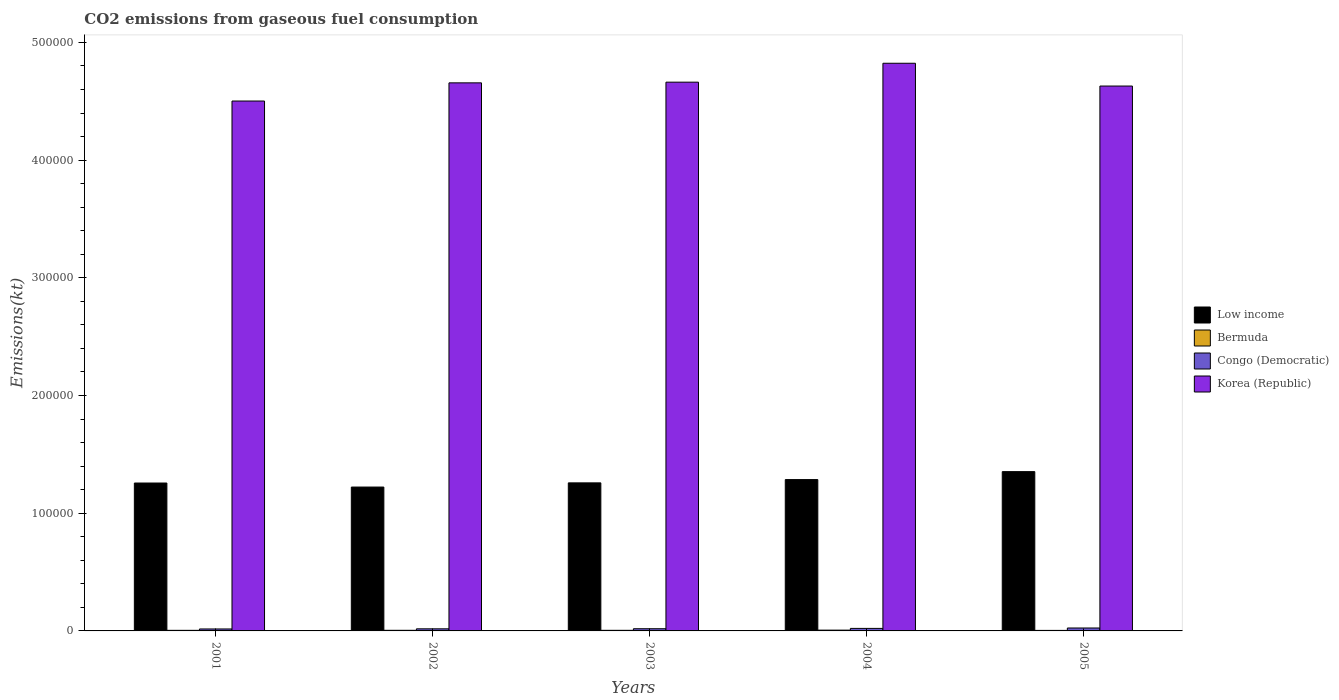How many different coloured bars are there?
Provide a succinct answer. 4. How many groups of bars are there?
Offer a very short reply. 5. Are the number of bars on each tick of the X-axis equal?
Provide a succinct answer. Yes. How many bars are there on the 2nd tick from the left?
Offer a terse response. 4. What is the label of the 1st group of bars from the left?
Ensure brevity in your answer.  2001. What is the amount of CO2 emitted in Korea (Republic) in 2002?
Keep it short and to the point. 4.66e+05. Across all years, what is the maximum amount of CO2 emitted in Congo (Democratic)?
Your answer should be compact. 2486.23. Across all years, what is the minimum amount of CO2 emitted in Congo (Democratic)?
Ensure brevity in your answer.  1664.82. In which year was the amount of CO2 emitted in Bermuda minimum?
Make the answer very short. 2005. What is the total amount of CO2 emitted in Bermuda in the graph?
Ensure brevity in your answer.  2643.91. What is the difference between the amount of CO2 emitted in Bermuda in 2003 and that in 2005?
Offer a very short reply. 66.01. What is the difference between the amount of CO2 emitted in Bermuda in 2003 and the amount of CO2 emitted in Korea (Republic) in 2004?
Give a very brief answer. -4.82e+05. What is the average amount of CO2 emitted in Congo (Democratic) per year?
Offer a terse response. 1986.78. In the year 2001, what is the difference between the amount of CO2 emitted in Congo (Democratic) and amount of CO2 emitted in Low income?
Give a very brief answer. -1.24e+05. What is the ratio of the amount of CO2 emitted in Korea (Republic) in 2001 to that in 2003?
Offer a very short reply. 0.97. Is the amount of CO2 emitted in Bermuda in 2002 less than that in 2005?
Give a very brief answer. No. Is the difference between the amount of CO2 emitted in Congo (Democratic) in 2003 and 2004 greater than the difference between the amount of CO2 emitted in Low income in 2003 and 2004?
Your response must be concise. Yes. What is the difference between the highest and the second highest amount of CO2 emitted in Bermuda?
Give a very brief answer. 146.68. What is the difference between the highest and the lowest amount of CO2 emitted in Bermuda?
Give a very brief answer. 227.35. In how many years, is the amount of CO2 emitted in Low income greater than the average amount of CO2 emitted in Low income taken over all years?
Ensure brevity in your answer.  2. Is the sum of the amount of CO2 emitted in Low income in 2002 and 2004 greater than the maximum amount of CO2 emitted in Congo (Democratic) across all years?
Provide a short and direct response. Yes. Is it the case that in every year, the sum of the amount of CO2 emitted in Bermuda and amount of CO2 emitted in Congo (Democratic) is greater than the sum of amount of CO2 emitted in Low income and amount of CO2 emitted in Korea (Republic)?
Offer a terse response. No. How many bars are there?
Keep it short and to the point. 20. How many years are there in the graph?
Give a very brief answer. 5. Are the values on the major ticks of Y-axis written in scientific E-notation?
Your response must be concise. No. Does the graph contain grids?
Provide a succinct answer. No. How are the legend labels stacked?
Your answer should be compact. Vertical. What is the title of the graph?
Give a very brief answer. CO2 emissions from gaseous fuel consumption. What is the label or title of the Y-axis?
Give a very brief answer. Emissions(kt). What is the Emissions(kt) in Low income in 2001?
Your answer should be compact. 1.26e+05. What is the Emissions(kt) of Bermuda in 2001?
Your answer should be compact. 495.05. What is the Emissions(kt) of Congo (Democratic) in 2001?
Offer a very short reply. 1664.82. What is the Emissions(kt) of Korea (Republic) in 2001?
Offer a terse response. 4.50e+05. What is the Emissions(kt) in Low income in 2002?
Make the answer very short. 1.22e+05. What is the Emissions(kt) of Bermuda in 2002?
Make the answer very short. 524.38. What is the Emissions(kt) of Congo (Democratic) in 2002?
Ensure brevity in your answer.  1782.16. What is the Emissions(kt) in Korea (Republic) in 2002?
Ensure brevity in your answer.  4.66e+05. What is the Emissions(kt) in Low income in 2003?
Make the answer very short. 1.26e+05. What is the Emissions(kt) of Bermuda in 2003?
Provide a succinct answer. 509.71. What is the Emissions(kt) of Congo (Democratic) in 2003?
Provide a succinct answer. 1862.84. What is the Emissions(kt) of Korea (Republic) in 2003?
Keep it short and to the point. 4.66e+05. What is the Emissions(kt) in Low income in 2004?
Offer a very short reply. 1.29e+05. What is the Emissions(kt) in Bermuda in 2004?
Ensure brevity in your answer.  671.06. What is the Emissions(kt) of Congo (Democratic) in 2004?
Ensure brevity in your answer.  2137.86. What is the Emissions(kt) in Korea (Republic) in 2004?
Provide a short and direct response. 4.82e+05. What is the Emissions(kt) of Low income in 2005?
Keep it short and to the point. 1.35e+05. What is the Emissions(kt) in Bermuda in 2005?
Ensure brevity in your answer.  443.71. What is the Emissions(kt) in Congo (Democratic) in 2005?
Keep it short and to the point. 2486.23. What is the Emissions(kt) in Korea (Republic) in 2005?
Your answer should be very brief. 4.63e+05. Across all years, what is the maximum Emissions(kt) of Low income?
Offer a terse response. 1.35e+05. Across all years, what is the maximum Emissions(kt) in Bermuda?
Make the answer very short. 671.06. Across all years, what is the maximum Emissions(kt) in Congo (Democratic)?
Provide a short and direct response. 2486.23. Across all years, what is the maximum Emissions(kt) in Korea (Republic)?
Keep it short and to the point. 4.82e+05. Across all years, what is the minimum Emissions(kt) of Low income?
Keep it short and to the point. 1.22e+05. Across all years, what is the minimum Emissions(kt) of Bermuda?
Your answer should be very brief. 443.71. Across all years, what is the minimum Emissions(kt) in Congo (Democratic)?
Provide a succinct answer. 1664.82. Across all years, what is the minimum Emissions(kt) of Korea (Republic)?
Give a very brief answer. 4.50e+05. What is the total Emissions(kt) in Low income in the graph?
Your response must be concise. 6.38e+05. What is the total Emissions(kt) of Bermuda in the graph?
Give a very brief answer. 2643.91. What is the total Emissions(kt) of Congo (Democratic) in the graph?
Provide a succinct answer. 9933.9. What is the total Emissions(kt) in Korea (Republic) in the graph?
Provide a short and direct response. 2.33e+06. What is the difference between the Emissions(kt) in Low income in 2001 and that in 2002?
Keep it short and to the point. 3417.64. What is the difference between the Emissions(kt) in Bermuda in 2001 and that in 2002?
Ensure brevity in your answer.  -29.34. What is the difference between the Emissions(kt) in Congo (Democratic) in 2001 and that in 2002?
Provide a succinct answer. -117.34. What is the difference between the Emissions(kt) in Korea (Republic) in 2001 and that in 2002?
Offer a terse response. -1.54e+04. What is the difference between the Emissions(kt) of Low income in 2001 and that in 2003?
Provide a short and direct response. -132.01. What is the difference between the Emissions(kt) of Bermuda in 2001 and that in 2003?
Make the answer very short. -14.67. What is the difference between the Emissions(kt) in Congo (Democratic) in 2001 and that in 2003?
Your answer should be compact. -198.02. What is the difference between the Emissions(kt) of Korea (Republic) in 2001 and that in 2003?
Give a very brief answer. -1.60e+04. What is the difference between the Emissions(kt) in Low income in 2001 and that in 2004?
Provide a succinct answer. -2926.27. What is the difference between the Emissions(kt) of Bermuda in 2001 and that in 2004?
Offer a very short reply. -176.02. What is the difference between the Emissions(kt) of Congo (Democratic) in 2001 and that in 2004?
Keep it short and to the point. -473.04. What is the difference between the Emissions(kt) of Korea (Republic) in 2001 and that in 2004?
Offer a very short reply. -3.21e+04. What is the difference between the Emissions(kt) of Low income in 2001 and that in 2005?
Ensure brevity in your answer.  -9673.55. What is the difference between the Emissions(kt) in Bermuda in 2001 and that in 2005?
Make the answer very short. 51.34. What is the difference between the Emissions(kt) of Congo (Democratic) in 2001 and that in 2005?
Keep it short and to the point. -821.41. What is the difference between the Emissions(kt) of Korea (Republic) in 2001 and that in 2005?
Offer a very short reply. -1.27e+04. What is the difference between the Emissions(kt) of Low income in 2002 and that in 2003?
Your answer should be compact. -3549.66. What is the difference between the Emissions(kt) of Bermuda in 2002 and that in 2003?
Offer a terse response. 14.67. What is the difference between the Emissions(kt) of Congo (Democratic) in 2002 and that in 2003?
Your response must be concise. -80.67. What is the difference between the Emissions(kt) in Korea (Republic) in 2002 and that in 2003?
Offer a terse response. -583.05. What is the difference between the Emissions(kt) in Low income in 2002 and that in 2004?
Ensure brevity in your answer.  -6343.91. What is the difference between the Emissions(kt) of Bermuda in 2002 and that in 2004?
Provide a short and direct response. -146.68. What is the difference between the Emissions(kt) of Congo (Democratic) in 2002 and that in 2004?
Provide a succinct answer. -355.7. What is the difference between the Emissions(kt) in Korea (Republic) in 2002 and that in 2004?
Give a very brief answer. -1.66e+04. What is the difference between the Emissions(kt) in Low income in 2002 and that in 2005?
Keep it short and to the point. -1.31e+04. What is the difference between the Emissions(kt) of Bermuda in 2002 and that in 2005?
Provide a succinct answer. 80.67. What is the difference between the Emissions(kt) in Congo (Democratic) in 2002 and that in 2005?
Give a very brief answer. -704.06. What is the difference between the Emissions(kt) of Korea (Republic) in 2002 and that in 2005?
Your response must be concise. 2709.91. What is the difference between the Emissions(kt) in Low income in 2003 and that in 2004?
Ensure brevity in your answer.  -2794.25. What is the difference between the Emissions(kt) in Bermuda in 2003 and that in 2004?
Your answer should be very brief. -161.35. What is the difference between the Emissions(kt) in Congo (Democratic) in 2003 and that in 2004?
Offer a very short reply. -275.02. What is the difference between the Emissions(kt) in Korea (Republic) in 2003 and that in 2004?
Offer a terse response. -1.61e+04. What is the difference between the Emissions(kt) in Low income in 2003 and that in 2005?
Make the answer very short. -9541.53. What is the difference between the Emissions(kt) of Bermuda in 2003 and that in 2005?
Your answer should be compact. 66.01. What is the difference between the Emissions(kt) of Congo (Democratic) in 2003 and that in 2005?
Give a very brief answer. -623.39. What is the difference between the Emissions(kt) of Korea (Republic) in 2003 and that in 2005?
Provide a short and direct response. 3292.97. What is the difference between the Emissions(kt) in Low income in 2004 and that in 2005?
Ensure brevity in your answer.  -6747.28. What is the difference between the Emissions(kt) of Bermuda in 2004 and that in 2005?
Offer a terse response. 227.35. What is the difference between the Emissions(kt) of Congo (Democratic) in 2004 and that in 2005?
Your response must be concise. -348.37. What is the difference between the Emissions(kt) in Korea (Republic) in 2004 and that in 2005?
Your answer should be compact. 1.94e+04. What is the difference between the Emissions(kt) of Low income in 2001 and the Emissions(kt) of Bermuda in 2002?
Provide a short and direct response. 1.25e+05. What is the difference between the Emissions(kt) in Low income in 2001 and the Emissions(kt) in Congo (Democratic) in 2002?
Keep it short and to the point. 1.24e+05. What is the difference between the Emissions(kt) in Low income in 2001 and the Emissions(kt) in Korea (Republic) in 2002?
Keep it short and to the point. -3.40e+05. What is the difference between the Emissions(kt) of Bermuda in 2001 and the Emissions(kt) of Congo (Democratic) in 2002?
Ensure brevity in your answer.  -1287.12. What is the difference between the Emissions(kt) of Bermuda in 2001 and the Emissions(kt) of Korea (Republic) in 2002?
Your response must be concise. -4.65e+05. What is the difference between the Emissions(kt) of Congo (Democratic) in 2001 and the Emissions(kt) of Korea (Republic) in 2002?
Provide a short and direct response. -4.64e+05. What is the difference between the Emissions(kt) in Low income in 2001 and the Emissions(kt) in Bermuda in 2003?
Provide a short and direct response. 1.25e+05. What is the difference between the Emissions(kt) in Low income in 2001 and the Emissions(kt) in Congo (Democratic) in 2003?
Offer a very short reply. 1.24e+05. What is the difference between the Emissions(kt) in Low income in 2001 and the Emissions(kt) in Korea (Republic) in 2003?
Your answer should be very brief. -3.41e+05. What is the difference between the Emissions(kt) of Bermuda in 2001 and the Emissions(kt) of Congo (Democratic) in 2003?
Ensure brevity in your answer.  -1367.79. What is the difference between the Emissions(kt) in Bermuda in 2001 and the Emissions(kt) in Korea (Republic) in 2003?
Offer a very short reply. -4.66e+05. What is the difference between the Emissions(kt) of Congo (Democratic) in 2001 and the Emissions(kt) of Korea (Republic) in 2003?
Offer a terse response. -4.65e+05. What is the difference between the Emissions(kt) of Low income in 2001 and the Emissions(kt) of Bermuda in 2004?
Provide a succinct answer. 1.25e+05. What is the difference between the Emissions(kt) in Low income in 2001 and the Emissions(kt) in Congo (Democratic) in 2004?
Your answer should be compact. 1.24e+05. What is the difference between the Emissions(kt) of Low income in 2001 and the Emissions(kt) of Korea (Republic) in 2004?
Provide a succinct answer. -3.57e+05. What is the difference between the Emissions(kt) in Bermuda in 2001 and the Emissions(kt) in Congo (Democratic) in 2004?
Keep it short and to the point. -1642.82. What is the difference between the Emissions(kt) in Bermuda in 2001 and the Emissions(kt) in Korea (Republic) in 2004?
Your answer should be very brief. -4.82e+05. What is the difference between the Emissions(kt) in Congo (Democratic) in 2001 and the Emissions(kt) in Korea (Republic) in 2004?
Keep it short and to the point. -4.81e+05. What is the difference between the Emissions(kt) of Low income in 2001 and the Emissions(kt) of Bermuda in 2005?
Offer a terse response. 1.25e+05. What is the difference between the Emissions(kt) in Low income in 2001 and the Emissions(kt) in Congo (Democratic) in 2005?
Make the answer very short. 1.23e+05. What is the difference between the Emissions(kt) in Low income in 2001 and the Emissions(kt) in Korea (Republic) in 2005?
Offer a terse response. -3.37e+05. What is the difference between the Emissions(kt) of Bermuda in 2001 and the Emissions(kt) of Congo (Democratic) in 2005?
Keep it short and to the point. -1991.18. What is the difference between the Emissions(kt) of Bermuda in 2001 and the Emissions(kt) of Korea (Republic) in 2005?
Provide a short and direct response. -4.62e+05. What is the difference between the Emissions(kt) of Congo (Democratic) in 2001 and the Emissions(kt) of Korea (Republic) in 2005?
Offer a very short reply. -4.61e+05. What is the difference between the Emissions(kt) of Low income in 2002 and the Emissions(kt) of Bermuda in 2003?
Provide a short and direct response. 1.22e+05. What is the difference between the Emissions(kt) in Low income in 2002 and the Emissions(kt) in Congo (Democratic) in 2003?
Ensure brevity in your answer.  1.20e+05. What is the difference between the Emissions(kt) of Low income in 2002 and the Emissions(kt) of Korea (Republic) in 2003?
Make the answer very short. -3.44e+05. What is the difference between the Emissions(kt) of Bermuda in 2002 and the Emissions(kt) of Congo (Democratic) in 2003?
Make the answer very short. -1338.45. What is the difference between the Emissions(kt) in Bermuda in 2002 and the Emissions(kt) in Korea (Republic) in 2003?
Make the answer very short. -4.66e+05. What is the difference between the Emissions(kt) in Congo (Democratic) in 2002 and the Emissions(kt) in Korea (Republic) in 2003?
Offer a terse response. -4.64e+05. What is the difference between the Emissions(kt) in Low income in 2002 and the Emissions(kt) in Bermuda in 2004?
Your answer should be compact. 1.22e+05. What is the difference between the Emissions(kt) in Low income in 2002 and the Emissions(kt) in Congo (Democratic) in 2004?
Make the answer very short. 1.20e+05. What is the difference between the Emissions(kt) of Low income in 2002 and the Emissions(kt) of Korea (Republic) in 2004?
Your answer should be compact. -3.60e+05. What is the difference between the Emissions(kt) in Bermuda in 2002 and the Emissions(kt) in Congo (Democratic) in 2004?
Ensure brevity in your answer.  -1613.48. What is the difference between the Emissions(kt) in Bermuda in 2002 and the Emissions(kt) in Korea (Republic) in 2004?
Your response must be concise. -4.82e+05. What is the difference between the Emissions(kt) in Congo (Democratic) in 2002 and the Emissions(kt) in Korea (Republic) in 2004?
Give a very brief answer. -4.80e+05. What is the difference between the Emissions(kt) of Low income in 2002 and the Emissions(kt) of Bermuda in 2005?
Give a very brief answer. 1.22e+05. What is the difference between the Emissions(kt) in Low income in 2002 and the Emissions(kt) in Congo (Democratic) in 2005?
Make the answer very short. 1.20e+05. What is the difference between the Emissions(kt) in Low income in 2002 and the Emissions(kt) in Korea (Republic) in 2005?
Make the answer very short. -3.41e+05. What is the difference between the Emissions(kt) in Bermuda in 2002 and the Emissions(kt) in Congo (Democratic) in 2005?
Provide a succinct answer. -1961.85. What is the difference between the Emissions(kt) of Bermuda in 2002 and the Emissions(kt) of Korea (Republic) in 2005?
Offer a very short reply. -4.62e+05. What is the difference between the Emissions(kt) of Congo (Democratic) in 2002 and the Emissions(kt) of Korea (Republic) in 2005?
Your response must be concise. -4.61e+05. What is the difference between the Emissions(kt) of Low income in 2003 and the Emissions(kt) of Bermuda in 2004?
Give a very brief answer. 1.25e+05. What is the difference between the Emissions(kt) of Low income in 2003 and the Emissions(kt) of Congo (Democratic) in 2004?
Your answer should be very brief. 1.24e+05. What is the difference between the Emissions(kt) in Low income in 2003 and the Emissions(kt) in Korea (Republic) in 2004?
Your answer should be very brief. -3.56e+05. What is the difference between the Emissions(kt) of Bermuda in 2003 and the Emissions(kt) of Congo (Democratic) in 2004?
Offer a terse response. -1628.15. What is the difference between the Emissions(kt) in Bermuda in 2003 and the Emissions(kt) in Korea (Republic) in 2004?
Your answer should be very brief. -4.82e+05. What is the difference between the Emissions(kt) of Congo (Democratic) in 2003 and the Emissions(kt) of Korea (Republic) in 2004?
Offer a terse response. -4.80e+05. What is the difference between the Emissions(kt) in Low income in 2003 and the Emissions(kt) in Bermuda in 2005?
Make the answer very short. 1.25e+05. What is the difference between the Emissions(kt) of Low income in 2003 and the Emissions(kt) of Congo (Democratic) in 2005?
Keep it short and to the point. 1.23e+05. What is the difference between the Emissions(kt) in Low income in 2003 and the Emissions(kt) in Korea (Republic) in 2005?
Make the answer very short. -3.37e+05. What is the difference between the Emissions(kt) of Bermuda in 2003 and the Emissions(kt) of Congo (Democratic) in 2005?
Ensure brevity in your answer.  -1976.51. What is the difference between the Emissions(kt) of Bermuda in 2003 and the Emissions(kt) of Korea (Republic) in 2005?
Offer a very short reply. -4.62e+05. What is the difference between the Emissions(kt) in Congo (Democratic) in 2003 and the Emissions(kt) in Korea (Republic) in 2005?
Make the answer very short. -4.61e+05. What is the difference between the Emissions(kt) of Low income in 2004 and the Emissions(kt) of Bermuda in 2005?
Your response must be concise. 1.28e+05. What is the difference between the Emissions(kt) of Low income in 2004 and the Emissions(kt) of Congo (Democratic) in 2005?
Your answer should be very brief. 1.26e+05. What is the difference between the Emissions(kt) of Low income in 2004 and the Emissions(kt) of Korea (Republic) in 2005?
Your response must be concise. -3.34e+05. What is the difference between the Emissions(kt) of Bermuda in 2004 and the Emissions(kt) of Congo (Democratic) in 2005?
Give a very brief answer. -1815.16. What is the difference between the Emissions(kt) of Bermuda in 2004 and the Emissions(kt) of Korea (Republic) in 2005?
Provide a succinct answer. -4.62e+05. What is the difference between the Emissions(kt) in Congo (Democratic) in 2004 and the Emissions(kt) in Korea (Republic) in 2005?
Your answer should be very brief. -4.61e+05. What is the average Emissions(kt) of Low income per year?
Keep it short and to the point. 1.28e+05. What is the average Emissions(kt) of Bermuda per year?
Offer a very short reply. 528.78. What is the average Emissions(kt) of Congo (Democratic) per year?
Your response must be concise. 1986.78. What is the average Emissions(kt) of Korea (Republic) per year?
Ensure brevity in your answer.  4.65e+05. In the year 2001, what is the difference between the Emissions(kt) in Low income and Emissions(kt) in Bermuda?
Your response must be concise. 1.25e+05. In the year 2001, what is the difference between the Emissions(kt) of Low income and Emissions(kt) of Congo (Democratic)?
Keep it short and to the point. 1.24e+05. In the year 2001, what is the difference between the Emissions(kt) in Low income and Emissions(kt) in Korea (Republic)?
Your answer should be very brief. -3.25e+05. In the year 2001, what is the difference between the Emissions(kt) of Bermuda and Emissions(kt) of Congo (Democratic)?
Your answer should be very brief. -1169.77. In the year 2001, what is the difference between the Emissions(kt) of Bermuda and Emissions(kt) of Korea (Republic)?
Offer a terse response. -4.50e+05. In the year 2001, what is the difference between the Emissions(kt) of Congo (Democratic) and Emissions(kt) of Korea (Republic)?
Provide a short and direct response. -4.49e+05. In the year 2002, what is the difference between the Emissions(kt) in Low income and Emissions(kt) in Bermuda?
Offer a terse response. 1.22e+05. In the year 2002, what is the difference between the Emissions(kt) in Low income and Emissions(kt) in Congo (Democratic)?
Offer a terse response. 1.20e+05. In the year 2002, what is the difference between the Emissions(kt) of Low income and Emissions(kt) of Korea (Republic)?
Your answer should be very brief. -3.43e+05. In the year 2002, what is the difference between the Emissions(kt) in Bermuda and Emissions(kt) in Congo (Democratic)?
Give a very brief answer. -1257.78. In the year 2002, what is the difference between the Emissions(kt) in Bermuda and Emissions(kt) in Korea (Republic)?
Your answer should be very brief. -4.65e+05. In the year 2002, what is the difference between the Emissions(kt) of Congo (Democratic) and Emissions(kt) of Korea (Republic)?
Keep it short and to the point. -4.64e+05. In the year 2003, what is the difference between the Emissions(kt) of Low income and Emissions(kt) of Bermuda?
Your response must be concise. 1.25e+05. In the year 2003, what is the difference between the Emissions(kt) in Low income and Emissions(kt) in Congo (Democratic)?
Your response must be concise. 1.24e+05. In the year 2003, what is the difference between the Emissions(kt) in Low income and Emissions(kt) in Korea (Republic)?
Keep it short and to the point. -3.40e+05. In the year 2003, what is the difference between the Emissions(kt) of Bermuda and Emissions(kt) of Congo (Democratic)?
Offer a terse response. -1353.12. In the year 2003, what is the difference between the Emissions(kt) in Bermuda and Emissions(kt) in Korea (Republic)?
Give a very brief answer. -4.66e+05. In the year 2003, what is the difference between the Emissions(kt) of Congo (Democratic) and Emissions(kt) of Korea (Republic)?
Your answer should be compact. -4.64e+05. In the year 2004, what is the difference between the Emissions(kt) of Low income and Emissions(kt) of Bermuda?
Offer a very short reply. 1.28e+05. In the year 2004, what is the difference between the Emissions(kt) of Low income and Emissions(kt) of Congo (Democratic)?
Make the answer very short. 1.26e+05. In the year 2004, what is the difference between the Emissions(kt) of Low income and Emissions(kt) of Korea (Republic)?
Ensure brevity in your answer.  -3.54e+05. In the year 2004, what is the difference between the Emissions(kt) in Bermuda and Emissions(kt) in Congo (Democratic)?
Your answer should be very brief. -1466.8. In the year 2004, what is the difference between the Emissions(kt) in Bermuda and Emissions(kt) in Korea (Republic)?
Provide a succinct answer. -4.82e+05. In the year 2004, what is the difference between the Emissions(kt) of Congo (Democratic) and Emissions(kt) of Korea (Republic)?
Offer a very short reply. -4.80e+05. In the year 2005, what is the difference between the Emissions(kt) in Low income and Emissions(kt) in Bermuda?
Make the answer very short. 1.35e+05. In the year 2005, what is the difference between the Emissions(kt) in Low income and Emissions(kt) in Congo (Democratic)?
Give a very brief answer. 1.33e+05. In the year 2005, what is the difference between the Emissions(kt) in Low income and Emissions(kt) in Korea (Republic)?
Keep it short and to the point. -3.28e+05. In the year 2005, what is the difference between the Emissions(kt) in Bermuda and Emissions(kt) in Congo (Democratic)?
Keep it short and to the point. -2042.52. In the year 2005, what is the difference between the Emissions(kt) of Bermuda and Emissions(kt) of Korea (Republic)?
Give a very brief answer. -4.62e+05. In the year 2005, what is the difference between the Emissions(kt) in Congo (Democratic) and Emissions(kt) in Korea (Republic)?
Offer a very short reply. -4.60e+05. What is the ratio of the Emissions(kt) in Low income in 2001 to that in 2002?
Offer a terse response. 1.03. What is the ratio of the Emissions(kt) of Bermuda in 2001 to that in 2002?
Make the answer very short. 0.94. What is the ratio of the Emissions(kt) of Congo (Democratic) in 2001 to that in 2002?
Provide a short and direct response. 0.93. What is the ratio of the Emissions(kt) of Korea (Republic) in 2001 to that in 2002?
Give a very brief answer. 0.97. What is the ratio of the Emissions(kt) of Low income in 2001 to that in 2003?
Keep it short and to the point. 1. What is the ratio of the Emissions(kt) of Bermuda in 2001 to that in 2003?
Ensure brevity in your answer.  0.97. What is the ratio of the Emissions(kt) in Congo (Democratic) in 2001 to that in 2003?
Keep it short and to the point. 0.89. What is the ratio of the Emissions(kt) in Korea (Republic) in 2001 to that in 2003?
Offer a very short reply. 0.97. What is the ratio of the Emissions(kt) of Low income in 2001 to that in 2004?
Your response must be concise. 0.98. What is the ratio of the Emissions(kt) of Bermuda in 2001 to that in 2004?
Give a very brief answer. 0.74. What is the ratio of the Emissions(kt) in Congo (Democratic) in 2001 to that in 2004?
Your answer should be compact. 0.78. What is the ratio of the Emissions(kt) of Korea (Republic) in 2001 to that in 2004?
Your answer should be very brief. 0.93. What is the ratio of the Emissions(kt) in Low income in 2001 to that in 2005?
Your answer should be compact. 0.93. What is the ratio of the Emissions(kt) in Bermuda in 2001 to that in 2005?
Make the answer very short. 1.12. What is the ratio of the Emissions(kt) of Congo (Democratic) in 2001 to that in 2005?
Your response must be concise. 0.67. What is the ratio of the Emissions(kt) in Korea (Republic) in 2001 to that in 2005?
Your answer should be very brief. 0.97. What is the ratio of the Emissions(kt) in Low income in 2002 to that in 2003?
Give a very brief answer. 0.97. What is the ratio of the Emissions(kt) of Bermuda in 2002 to that in 2003?
Your response must be concise. 1.03. What is the ratio of the Emissions(kt) of Congo (Democratic) in 2002 to that in 2003?
Offer a terse response. 0.96. What is the ratio of the Emissions(kt) of Korea (Republic) in 2002 to that in 2003?
Provide a succinct answer. 1. What is the ratio of the Emissions(kt) in Low income in 2002 to that in 2004?
Ensure brevity in your answer.  0.95. What is the ratio of the Emissions(kt) of Bermuda in 2002 to that in 2004?
Provide a succinct answer. 0.78. What is the ratio of the Emissions(kt) in Congo (Democratic) in 2002 to that in 2004?
Provide a succinct answer. 0.83. What is the ratio of the Emissions(kt) of Korea (Republic) in 2002 to that in 2004?
Offer a terse response. 0.97. What is the ratio of the Emissions(kt) in Low income in 2002 to that in 2005?
Provide a succinct answer. 0.9. What is the ratio of the Emissions(kt) of Bermuda in 2002 to that in 2005?
Make the answer very short. 1.18. What is the ratio of the Emissions(kt) in Congo (Democratic) in 2002 to that in 2005?
Keep it short and to the point. 0.72. What is the ratio of the Emissions(kt) in Korea (Republic) in 2002 to that in 2005?
Make the answer very short. 1.01. What is the ratio of the Emissions(kt) in Low income in 2003 to that in 2004?
Your response must be concise. 0.98. What is the ratio of the Emissions(kt) in Bermuda in 2003 to that in 2004?
Provide a short and direct response. 0.76. What is the ratio of the Emissions(kt) of Congo (Democratic) in 2003 to that in 2004?
Provide a short and direct response. 0.87. What is the ratio of the Emissions(kt) of Korea (Republic) in 2003 to that in 2004?
Provide a succinct answer. 0.97. What is the ratio of the Emissions(kt) of Low income in 2003 to that in 2005?
Provide a short and direct response. 0.93. What is the ratio of the Emissions(kt) in Bermuda in 2003 to that in 2005?
Provide a short and direct response. 1.15. What is the ratio of the Emissions(kt) in Congo (Democratic) in 2003 to that in 2005?
Ensure brevity in your answer.  0.75. What is the ratio of the Emissions(kt) of Korea (Republic) in 2003 to that in 2005?
Provide a short and direct response. 1.01. What is the ratio of the Emissions(kt) in Low income in 2004 to that in 2005?
Your answer should be very brief. 0.95. What is the ratio of the Emissions(kt) of Bermuda in 2004 to that in 2005?
Ensure brevity in your answer.  1.51. What is the ratio of the Emissions(kt) in Congo (Democratic) in 2004 to that in 2005?
Provide a short and direct response. 0.86. What is the ratio of the Emissions(kt) in Korea (Republic) in 2004 to that in 2005?
Provide a succinct answer. 1.04. What is the difference between the highest and the second highest Emissions(kt) in Low income?
Offer a terse response. 6747.28. What is the difference between the highest and the second highest Emissions(kt) in Bermuda?
Offer a terse response. 146.68. What is the difference between the highest and the second highest Emissions(kt) in Congo (Democratic)?
Your response must be concise. 348.37. What is the difference between the highest and the second highest Emissions(kt) in Korea (Republic)?
Ensure brevity in your answer.  1.61e+04. What is the difference between the highest and the lowest Emissions(kt) in Low income?
Offer a very short reply. 1.31e+04. What is the difference between the highest and the lowest Emissions(kt) in Bermuda?
Provide a short and direct response. 227.35. What is the difference between the highest and the lowest Emissions(kt) in Congo (Democratic)?
Ensure brevity in your answer.  821.41. What is the difference between the highest and the lowest Emissions(kt) of Korea (Republic)?
Your answer should be very brief. 3.21e+04. 